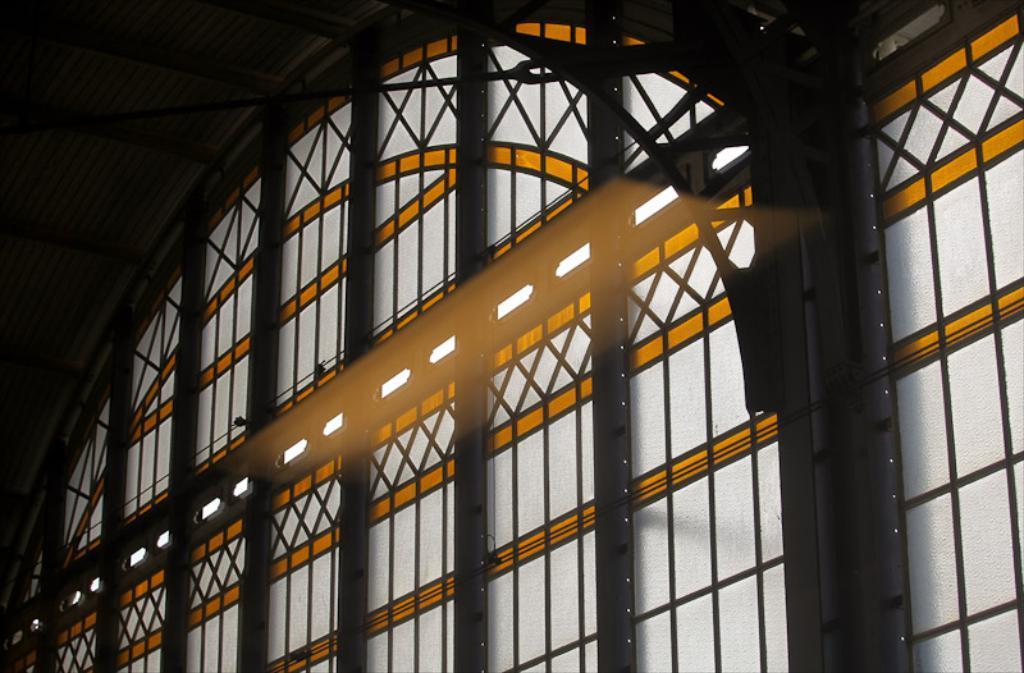In one or two sentences, can you explain what this image depicts? In this picture I can see there is a Iron frame and there is a glass window here. 